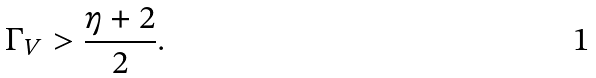<formula> <loc_0><loc_0><loc_500><loc_500>\Gamma _ { V } > \frac { \eta + 2 } { 2 } .</formula> 